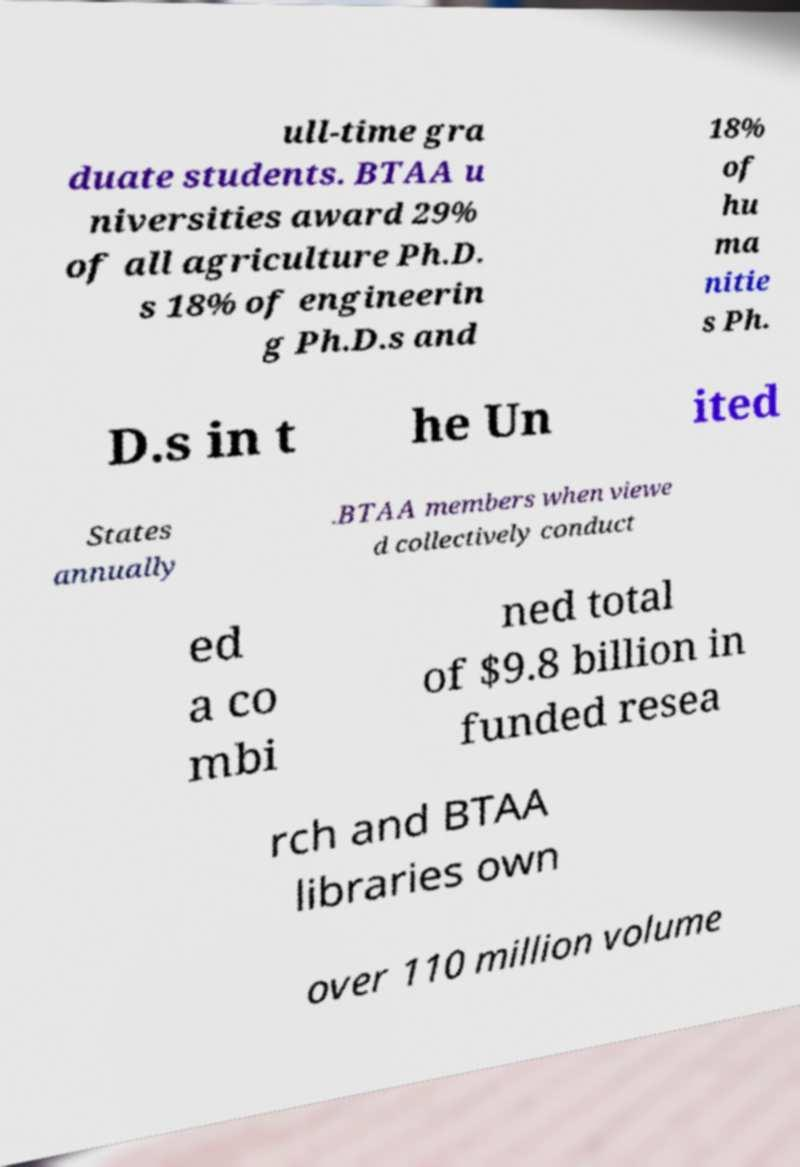Could you extract and type out the text from this image? ull-time gra duate students. BTAA u niversities award 29% of all agriculture Ph.D. s 18% of engineerin g Ph.D.s and 18% of hu ma nitie s Ph. D.s in t he Un ited States annually .BTAA members when viewe d collectively conduct ed a co mbi ned total of $9.8 billion in funded resea rch and BTAA libraries own over 110 million volume 